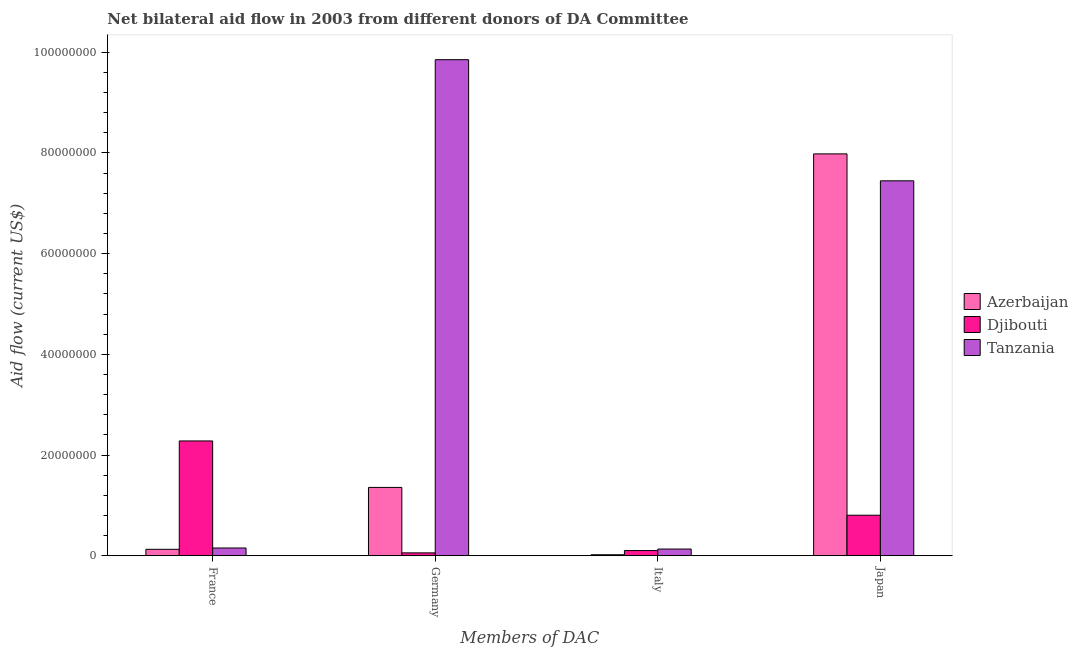Are the number of bars per tick equal to the number of legend labels?
Offer a very short reply. Yes. Are the number of bars on each tick of the X-axis equal?
Offer a terse response. Yes. How many bars are there on the 2nd tick from the right?
Provide a succinct answer. 3. What is the label of the 3rd group of bars from the left?
Make the answer very short. Italy. What is the amount of aid given by italy in Djibouti?
Provide a succinct answer. 1.04e+06. Across all countries, what is the maximum amount of aid given by germany?
Give a very brief answer. 9.85e+07. Across all countries, what is the minimum amount of aid given by japan?
Your answer should be compact. 8.06e+06. In which country was the amount of aid given by japan maximum?
Make the answer very short. Azerbaijan. In which country was the amount of aid given by germany minimum?
Provide a short and direct response. Djibouti. What is the total amount of aid given by germany in the graph?
Provide a succinct answer. 1.13e+08. What is the difference between the amount of aid given by germany in Tanzania and that in Djibouti?
Your response must be concise. 9.80e+07. What is the difference between the amount of aid given by germany in Djibouti and the amount of aid given by france in Azerbaijan?
Offer a very short reply. -7.10e+05. What is the average amount of aid given by france per country?
Offer a very short reply. 8.55e+06. What is the difference between the amount of aid given by germany and amount of aid given by france in Tanzania?
Ensure brevity in your answer.  9.70e+07. What is the ratio of the amount of aid given by italy in Azerbaijan to that in Djibouti?
Make the answer very short. 0.2. Is the amount of aid given by japan in Tanzania less than that in Azerbaijan?
Offer a very short reply. Yes. Is the difference between the amount of aid given by germany in Azerbaijan and Djibouti greater than the difference between the amount of aid given by france in Azerbaijan and Djibouti?
Keep it short and to the point. Yes. What is the difference between the highest and the second highest amount of aid given by france?
Provide a short and direct response. 2.13e+07. What is the difference between the highest and the lowest amount of aid given by japan?
Your answer should be compact. 7.18e+07. In how many countries, is the amount of aid given by france greater than the average amount of aid given by france taken over all countries?
Provide a succinct answer. 1. Is it the case that in every country, the sum of the amount of aid given by japan and amount of aid given by france is greater than the sum of amount of aid given by germany and amount of aid given by italy?
Provide a short and direct response. Yes. What does the 3rd bar from the left in Japan represents?
Offer a terse response. Tanzania. What does the 2nd bar from the right in Japan represents?
Offer a terse response. Djibouti. What is the difference between two consecutive major ticks on the Y-axis?
Offer a terse response. 2.00e+07. Are the values on the major ticks of Y-axis written in scientific E-notation?
Your answer should be very brief. No. Does the graph contain any zero values?
Make the answer very short. No. Does the graph contain grids?
Your answer should be very brief. No. How many legend labels are there?
Offer a terse response. 3. What is the title of the graph?
Keep it short and to the point. Net bilateral aid flow in 2003 from different donors of DA Committee. What is the label or title of the X-axis?
Ensure brevity in your answer.  Members of DAC. What is the Aid flow (current US$) in Azerbaijan in France?
Provide a short and direct response. 1.29e+06. What is the Aid flow (current US$) in Djibouti in France?
Provide a short and direct response. 2.28e+07. What is the Aid flow (current US$) in Tanzania in France?
Keep it short and to the point. 1.55e+06. What is the Aid flow (current US$) in Azerbaijan in Germany?
Offer a terse response. 1.36e+07. What is the Aid flow (current US$) of Djibouti in Germany?
Offer a terse response. 5.80e+05. What is the Aid flow (current US$) in Tanzania in Germany?
Give a very brief answer. 9.85e+07. What is the Aid flow (current US$) in Djibouti in Italy?
Give a very brief answer. 1.04e+06. What is the Aid flow (current US$) of Tanzania in Italy?
Your answer should be very brief. 1.34e+06. What is the Aid flow (current US$) of Azerbaijan in Japan?
Make the answer very short. 7.98e+07. What is the Aid flow (current US$) in Djibouti in Japan?
Ensure brevity in your answer.  8.06e+06. What is the Aid flow (current US$) of Tanzania in Japan?
Your answer should be very brief. 7.45e+07. Across all Members of DAC, what is the maximum Aid flow (current US$) in Azerbaijan?
Your answer should be very brief. 7.98e+07. Across all Members of DAC, what is the maximum Aid flow (current US$) in Djibouti?
Your answer should be compact. 2.28e+07. Across all Members of DAC, what is the maximum Aid flow (current US$) of Tanzania?
Provide a short and direct response. 9.85e+07. Across all Members of DAC, what is the minimum Aid flow (current US$) in Djibouti?
Offer a terse response. 5.80e+05. Across all Members of DAC, what is the minimum Aid flow (current US$) in Tanzania?
Ensure brevity in your answer.  1.34e+06. What is the total Aid flow (current US$) of Azerbaijan in the graph?
Give a very brief answer. 9.49e+07. What is the total Aid flow (current US$) of Djibouti in the graph?
Your answer should be very brief. 3.25e+07. What is the total Aid flow (current US$) of Tanzania in the graph?
Make the answer very short. 1.76e+08. What is the difference between the Aid flow (current US$) of Azerbaijan in France and that in Germany?
Provide a succinct answer. -1.23e+07. What is the difference between the Aid flow (current US$) of Djibouti in France and that in Germany?
Your response must be concise. 2.22e+07. What is the difference between the Aid flow (current US$) in Tanzania in France and that in Germany?
Your answer should be very brief. -9.70e+07. What is the difference between the Aid flow (current US$) of Azerbaijan in France and that in Italy?
Provide a succinct answer. 1.08e+06. What is the difference between the Aid flow (current US$) in Djibouti in France and that in Italy?
Provide a succinct answer. 2.18e+07. What is the difference between the Aid flow (current US$) of Azerbaijan in France and that in Japan?
Offer a very short reply. -7.85e+07. What is the difference between the Aid flow (current US$) in Djibouti in France and that in Japan?
Offer a terse response. 1.48e+07. What is the difference between the Aid flow (current US$) of Tanzania in France and that in Japan?
Your answer should be compact. -7.29e+07. What is the difference between the Aid flow (current US$) in Azerbaijan in Germany and that in Italy?
Your answer should be compact. 1.34e+07. What is the difference between the Aid flow (current US$) in Djibouti in Germany and that in Italy?
Provide a short and direct response. -4.60e+05. What is the difference between the Aid flow (current US$) in Tanzania in Germany and that in Italy?
Your answer should be compact. 9.72e+07. What is the difference between the Aid flow (current US$) in Azerbaijan in Germany and that in Japan?
Provide a short and direct response. -6.62e+07. What is the difference between the Aid flow (current US$) of Djibouti in Germany and that in Japan?
Keep it short and to the point. -7.48e+06. What is the difference between the Aid flow (current US$) of Tanzania in Germany and that in Japan?
Make the answer very short. 2.41e+07. What is the difference between the Aid flow (current US$) of Azerbaijan in Italy and that in Japan?
Your answer should be compact. -7.96e+07. What is the difference between the Aid flow (current US$) of Djibouti in Italy and that in Japan?
Keep it short and to the point. -7.02e+06. What is the difference between the Aid flow (current US$) in Tanzania in Italy and that in Japan?
Offer a terse response. -7.31e+07. What is the difference between the Aid flow (current US$) of Azerbaijan in France and the Aid flow (current US$) of Djibouti in Germany?
Offer a terse response. 7.10e+05. What is the difference between the Aid flow (current US$) of Azerbaijan in France and the Aid flow (current US$) of Tanzania in Germany?
Make the answer very short. -9.72e+07. What is the difference between the Aid flow (current US$) of Djibouti in France and the Aid flow (current US$) of Tanzania in Germany?
Keep it short and to the point. -7.57e+07. What is the difference between the Aid flow (current US$) of Djibouti in France and the Aid flow (current US$) of Tanzania in Italy?
Make the answer very short. 2.15e+07. What is the difference between the Aid flow (current US$) of Azerbaijan in France and the Aid flow (current US$) of Djibouti in Japan?
Provide a short and direct response. -6.77e+06. What is the difference between the Aid flow (current US$) of Azerbaijan in France and the Aid flow (current US$) of Tanzania in Japan?
Offer a terse response. -7.32e+07. What is the difference between the Aid flow (current US$) of Djibouti in France and the Aid flow (current US$) of Tanzania in Japan?
Give a very brief answer. -5.17e+07. What is the difference between the Aid flow (current US$) of Azerbaijan in Germany and the Aid flow (current US$) of Djibouti in Italy?
Offer a very short reply. 1.25e+07. What is the difference between the Aid flow (current US$) of Azerbaijan in Germany and the Aid flow (current US$) of Tanzania in Italy?
Provide a succinct answer. 1.22e+07. What is the difference between the Aid flow (current US$) in Djibouti in Germany and the Aid flow (current US$) in Tanzania in Italy?
Provide a short and direct response. -7.60e+05. What is the difference between the Aid flow (current US$) of Azerbaijan in Germany and the Aid flow (current US$) of Djibouti in Japan?
Provide a short and direct response. 5.52e+06. What is the difference between the Aid flow (current US$) in Azerbaijan in Germany and the Aid flow (current US$) in Tanzania in Japan?
Your response must be concise. -6.09e+07. What is the difference between the Aid flow (current US$) in Djibouti in Germany and the Aid flow (current US$) in Tanzania in Japan?
Give a very brief answer. -7.39e+07. What is the difference between the Aid flow (current US$) of Azerbaijan in Italy and the Aid flow (current US$) of Djibouti in Japan?
Ensure brevity in your answer.  -7.85e+06. What is the difference between the Aid flow (current US$) in Azerbaijan in Italy and the Aid flow (current US$) in Tanzania in Japan?
Your answer should be very brief. -7.43e+07. What is the difference between the Aid flow (current US$) in Djibouti in Italy and the Aid flow (current US$) in Tanzania in Japan?
Your answer should be very brief. -7.34e+07. What is the average Aid flow (current US$) in Azerbaijan per Members of DAC?
Keep it short and to the point. 2.37e+07. What is the average Aid flow (current US$) of Djibouti per Members of DAC?
Your response must be concise. 8.12e+06. What is the average Aid flow (current US$) of Tanzania per Members of DAC?
Ensure brevity in your answer.  4.40e+07. What is the difference between the Aid flow (current US$) of Azerbaijan and Aid flow (current US$) of Djibouti in France?
Your answer should be very brief. -2.15e+07. What is the difference between the Aid flow (current US$) of Azerbaijan and Aid flow (current US$) of Tanzania in France?
Keep it short and to the point. -2.60e+05. What is the difference between the Aid flow (current US$) in Djibouti and Aid flow (current US$) in Tanzania in France?
Offer a very short reply. 2.13e+07. What is the difference between the Aid flow (current US$) in Azerbaijan and Aid flow (current US$) in Djibouti in Germany?
Offer a very short reply. 1.30e+07. What is the difference between the Aid flow (current US$) of Azerbaijan and Aid flow (current US$) of Tanzania in Germany?
Give a very brief answer. -8.50e+07. What is the difference between the Aid flow (current US$) in Djibouti and Aid flow (current US$) in Tanzania in Germany?
Your answer should be very brief. -9.80e+07. What is the difference between the Aid flow (current US$) in Azerbaijan and Aid flow (current US$) in Djibouti in Italy?
Your response must be concise. -8.30e+05. What is the difference between the Aid flow (current US$) of Azerbaijan and Aid flow (current US$) of Tanzania in Italy?
Your response must be concise. -1.13e+06. What is the difference between the Aid flow (current US$) in Djibouti and Aid flow (current US$) in Tanzania in Italy?
Provide a succinct answer. -3.00e+05. What is the difference between the Aid flow (current US$) in Azerbaijan and Aid flow (current US$) in Djibouti in Japan?
Ensure brevity in your answer.  7.18e+07. What is the difference between the Aid flow (current US$) in Azerbaijan and Aid flow (current US$) in Tanzania in Japan?
Your answer should be very brief. 5.35e+06. What is the difference between the Aid flow (current US$) in Djibouti and Aid flow (current US$) in Tanzania in Japan?
Your answer should be compact. -6.64e+07. What is the ratio of the Aid flow (current US$) of Azerbaijan in France to that in Germany?
Offer a very short reply. 0.1. What is the ratio of the Aid flow (current US$) of Djibouti in France to that in Germany?
Ensure brevity in your answer.  39.33. What is the ratio of the Aid flow (current US$) of Tanzania in France to that in Germany?
Offer a terse response. 0.02. What is the ratio of the Aid flow (current US$) in Azerbaijan in France to that in Italy?
Provide a succinct answer. 6.14. What is the ratio of the Aid flow (current US$) of Djibouti in France to that in Italy?
Give a very brief answer. 21.93. What is the ratio of the Aid flow (current US$) of Tanzania in France to that in Italy?
Provide a short and direct response. 1.16. What is the ratio of the Aid flow (current US$) in Azerbaijan in France to that in Japan?
Provide a succinct answer. 0.02. What is the ratio of the Aid flow (current US$) of Djibouti in France to that in Japan?
Your answer should be very brief. 2.83. What is the ratio of the Aid flow (current US$) in Tanzania in France to that in Japan?
Offer a very short reply. 0.02. What is the ratio of the Aid flow (current US$) of Azerbaijan in Germany to that in Italy?
Your answer should be very brief. 64.67. What is the ratio of the Aid flow (current US$) in Djibouti in Germany to that in Italy?
Give a very brief answer. 0.56. What is the ratio of the Aid flow (current US$) of Tanzania in Germany to that in Italy?
Make the answer very short. 73.53. What is the ratio of the Aid flow (current US$) in Azerbaijan in Germany to that in Japan?
Your answer should be very brief. 0.17. What is the ratio of the Aid flow (current US$) in Djibouti in Germany to that in Japan?
Your response must be concise. 0.07. What is the ratio of the Aid flow (current US$) in Tanzania in Germany to that in Japan?
Offer a very short reply. 1.32. What is the ratio of the Aid flow (current US$) in Azerbaijan in Italy to that in Japan?
Keep it short and to the point. 0. What is the ratio of the Aid flow (current US$) of Djibouti in Italy to that in Japan?
Provide a short and direct response. 0.13. What is the ratio of the Aid flow (current US$) in Tanzania in Italy to that in Japan?
Your response must be concise. 0.02. What is the difference between the highest and the second highest Aid flow (current US$) in Azerbaijan?
Your response must be concise. 6.62e+07. What is the difference between the highest and the second highest Aid flow (current US$) in Djibouti?
Your answer should be very brief. 1.48e+07. What is the difference between the highest and the second highest Aid flow (current US$) of Tanzania?
Your answer should be very brief. 2.41e+07. What is the difference between the highest and the lowest Aid flow (current US$) of Azerbaijan?
Give a very brief answer. 7.96e+07. What is the difference between the highest and the lowest Aid flow (current US$) of Djibouti?
Provide a succinct answer. 2.22e+07. What is the difference between the highest and the lowest Aid flow (current US$) of Tanzania?
Give a very brief answer. 9.72e+07. 